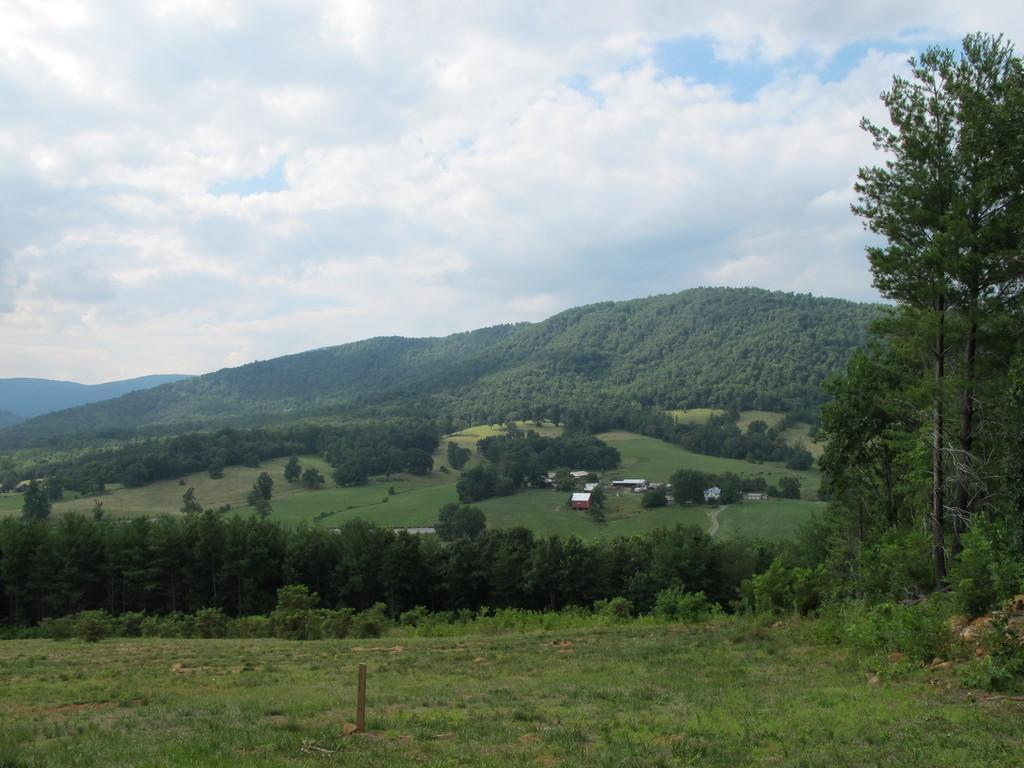What type of terrain is visible in the image? There are hills in the image. What part of the natural environment is visible in the image? The sky is visible in the image. What type of structures can be seen in the image? There are sheds in the image. What type of vegetation is present at the bottom of the image? There is grass at the bottom of the image. What type of living organisms can be seen in the image? Plants are present in the image. How many seeds are visible in the image? There are no seeds present in the image. Can you see a swing in the image? There is no swing present in the image. 